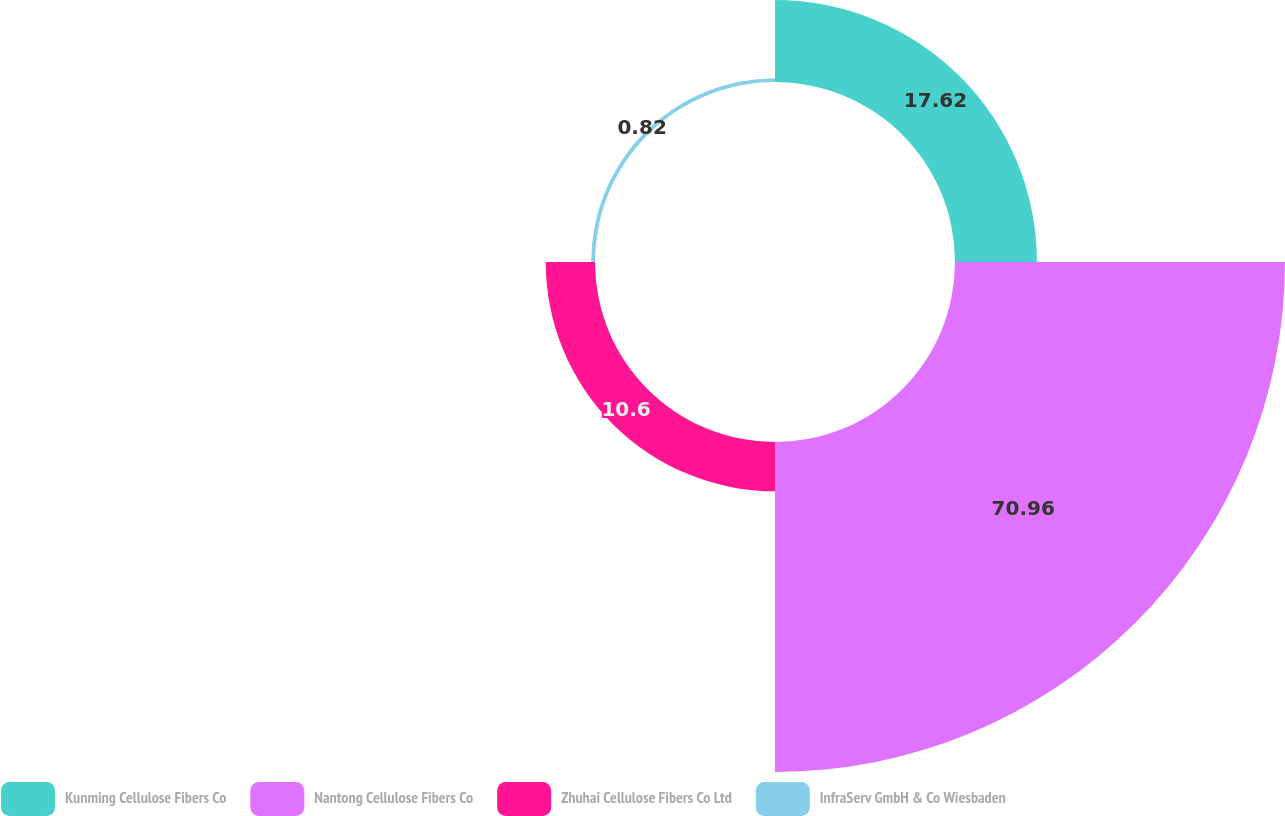<chart> <loc_0><loc_0><loc_500><loc_500><pie_chart><fcel>Kunming Cellulose Fibers Co<fcel>Nantong Cellulose Fibers Co<fcel>Zhuhai Cellulose Fibers Co Ltd<fcel>InfraServ GmbH & Co Wiesbaden<nl><fcel>17.62%<fcel>70.96%<fcel>10.6%<fcel>0.82%<nl></chart> 